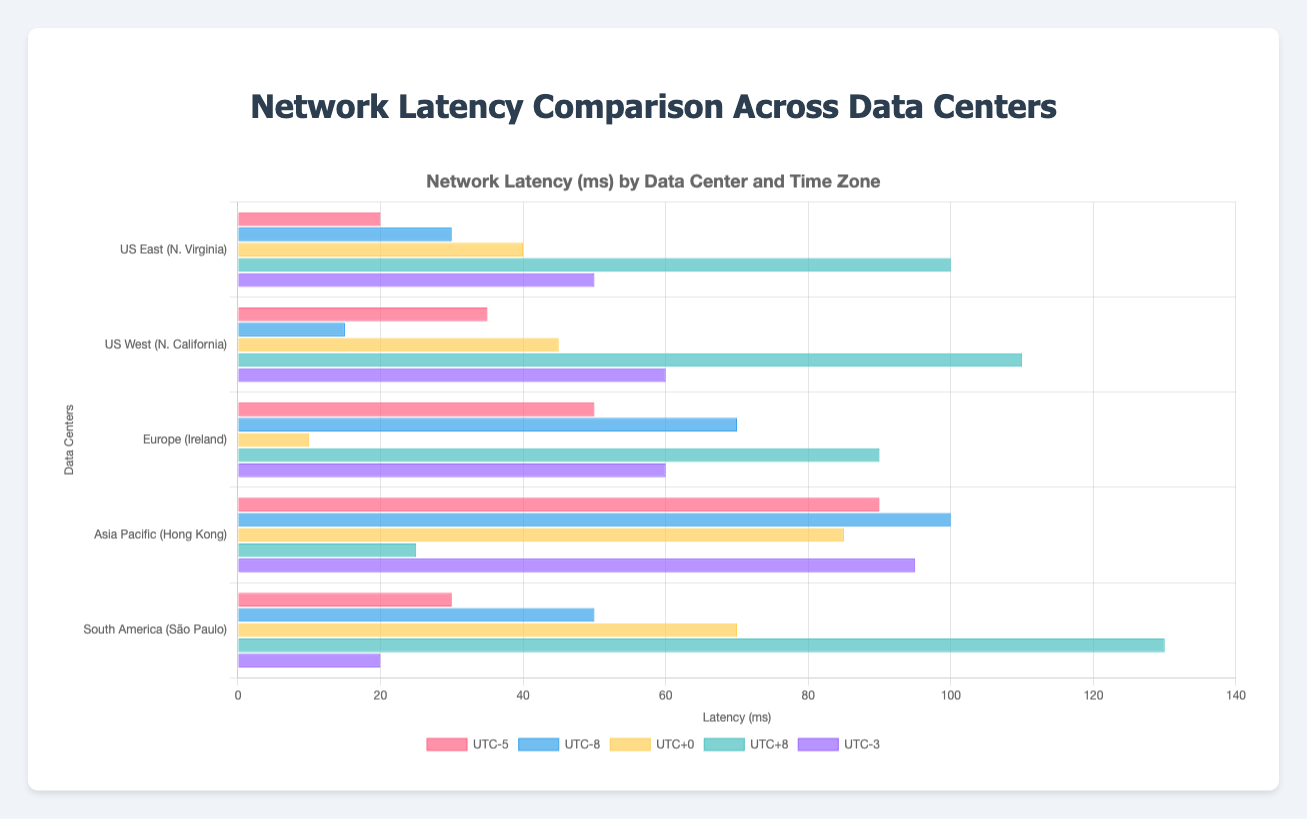Which data center has the lowest latency in the UTC-8 time zone? Look for the shortest bar among the "UTC-8" group of bars. "US West (N. California)" has the shortest bar for UTC-8.
Answer: US West (N. California) What is the difference in latency between "US East (N. Virginia)" and "Asia Pacific (Hong Kong)" for the UTC-5 time zone? Subtract the latency value of "US East (N. Virginia)" from that of "Asia Pacific (Hong Kong)" for the UTC-5 time zone: 90 - 20 = 70.
Answer: 70 Which data center shows the highest overall latency within the UTC+8 time zone? Look for the longest bar in the "UTC+8" group of bars. "South America (São Paulo)" has the longest bar for UTC+8.
Answer: South America (São Paulo) What is the average latency for "Europe (Ireland)" across all time zones? Add all latencies for "Europe (Ireland)" and then divide by the number of time zones: (50 + 70 + 10 + 90 + 60) / 5 = 280 / 5 = 56.
Answer: 56 How does the latency of "South America (São Paulo)" in the UTC-3 time zone compare to that in the UTC+0 time zone? Compare the heights of the bars for "South America (São Paulo)" in UTC-3 and UTC+0. UTC-3 (20) is less than UTC+0 (70).
Answer: Less Between "US West (N. California)" and "South America (São Paulo)", which data center has a higher latency in the UTC+0 time zone? Compare the bars of "US West (N. California)" and "South America (São Paulo)" for UTC+0. "South America (São Paulo)" has a higher latency (70 vs 45).
Answer: South America (São Paulo) In which time zone does "Asia Pacific (Hong Kong)" have the lowest latency? Look for the shortest bar within the "Asia Pacific (Hong Kong)" row. The shortest bar is for UTC+8, with latency 25.
Answer: UTC+8 Sum the latency values for "US East (N. Virginia)" and "Europe (Ireland)" in the UTC-3 time zone. Add the latency values for "US East (N. Virginia)" and "Europe (Ireland)" in the UTC-3 time zone: 50 + 60 = 110.
Answer: 110 Which time zone has the lowest average latency across all data centers? Calculate the average latency for each time zone and find the minimum. (1) UTC-5: (20 + 35 + 50 + 90 + 30) / 5 = 225 / 5 = 45, (2) UTC-8: (30 + 15 + 70 + 100 + 50) / 5 = 265 / 5 = 53, (3) UTC+0: (40 + 45 + 10 + 85 + 70) / 5 = 250 / 5 = 50, (4) UTC+8: (100 + 110 + 90 + 25 + 130) / 5 = 455 / 5 = 91, (5) UTC-3: (50 + 60 + 60 + 95 + 20) / 5 = 285 / 5 = 57. The lowest average latency is for UTC-5 with 45.
Answer: UTC-5 What is the overall range of latency values for "US West (N. California)"? Subtract the minimum latency from the maximum latency for "US West (N. California)": 110 - 15 = 95.
Answer: 95 